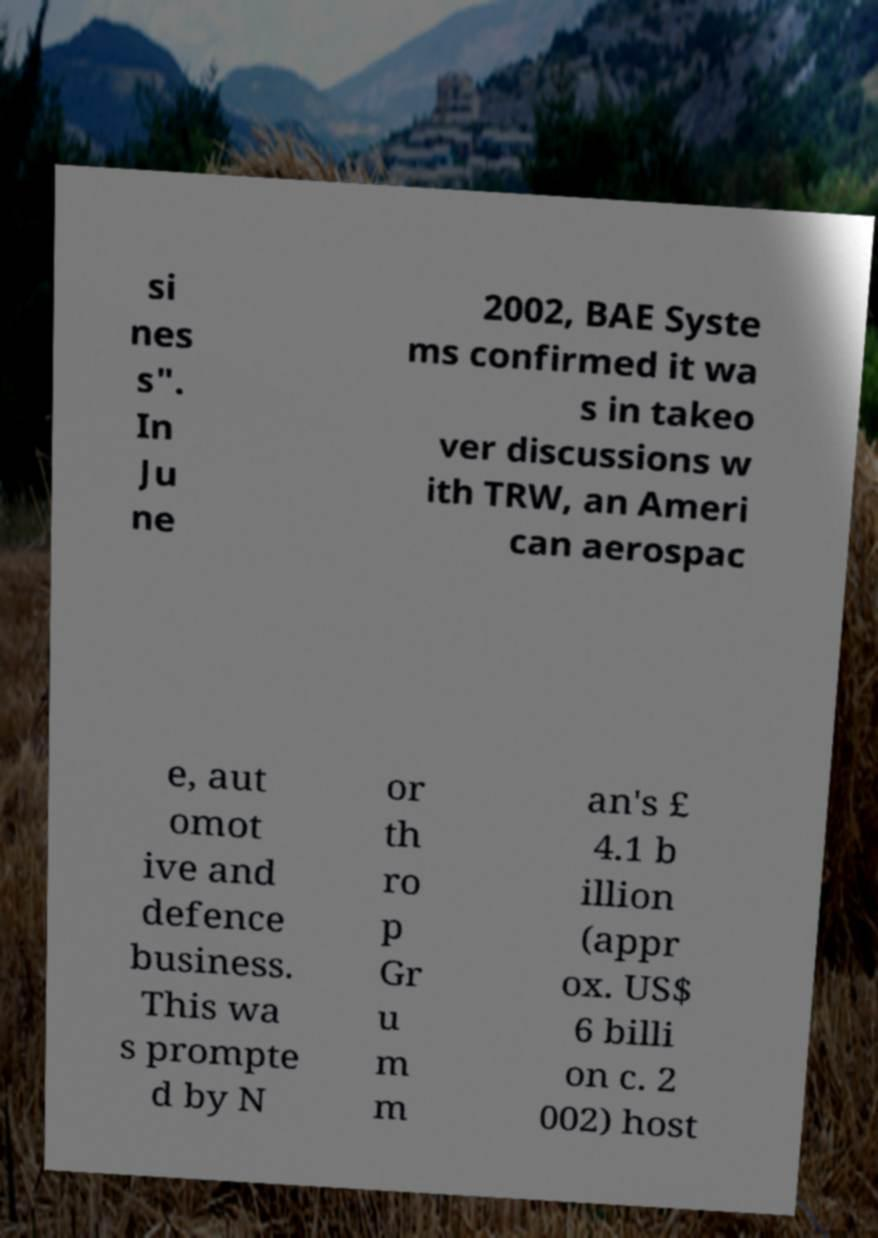Can you read and provide the text displayed in the image?This photo seems to have some interesting text. Can you extract and type it out for me? si nes s". In Ju ne 2002, BAE Syste ms confirmed it wa s in takeo ver discussions w ith TRW, an Ameri can aerospac e, aut omot ive and defence business. This wa s prompte d by N or th ro p Gr u m m an's £ 4.1 b illion (appr ox. US$ 6 billi on c. 2 002) host 